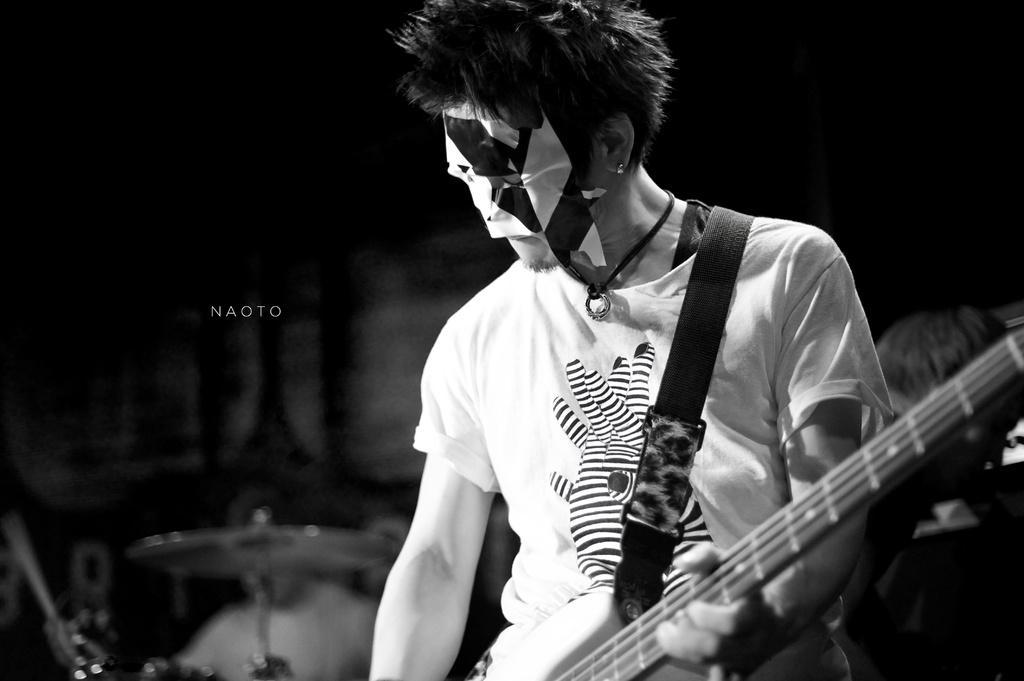In one or two sentences, can you explain what this image depicts? It is a black and white picture a man is standing and wearing a guitar he is wearing a mask to his face in the background there is also other musical equipment. 